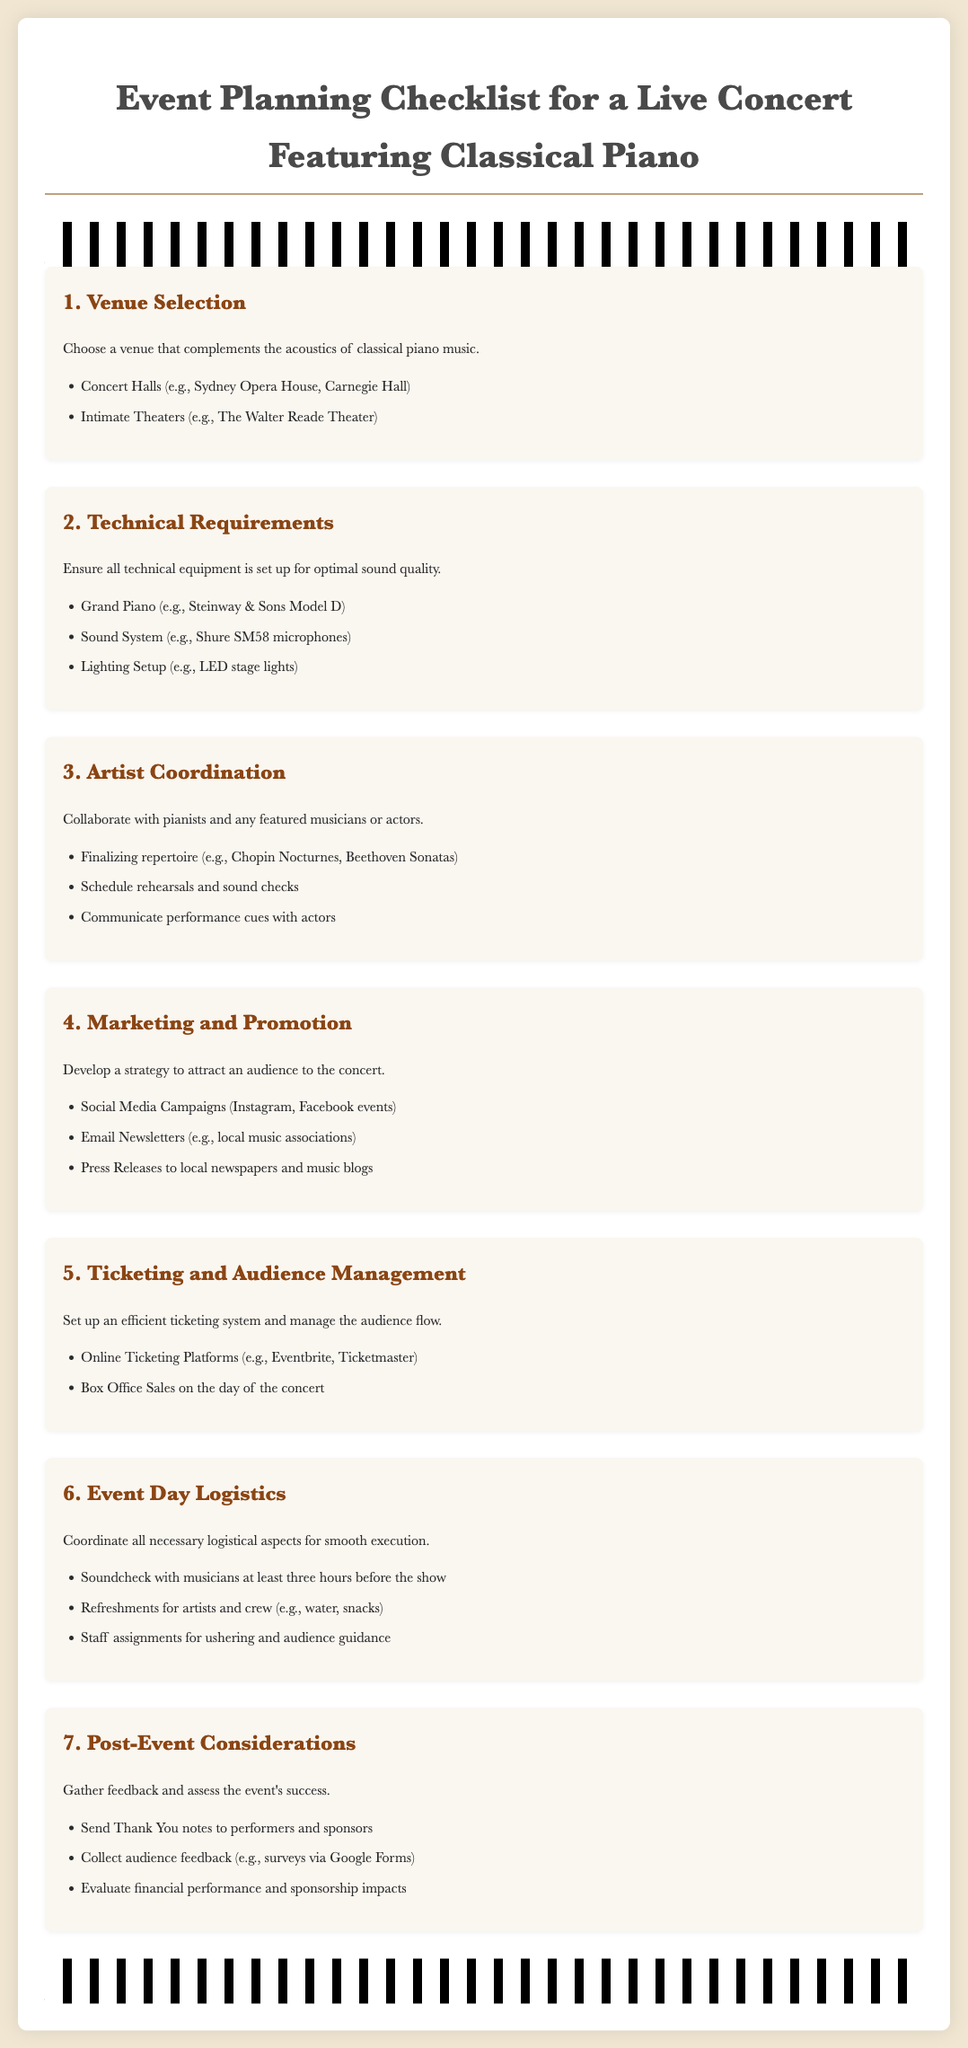What are two types of venues mentioned? The document lists different types of venues suitable for a classical piano concert, including concert halls and intimate theaters.
Answer: Concert Halls, Intimate Theaters What is one technical requirement for the concert? The document highlights a grand piano as one of the essential technical requirements for the concert.
Answer: Grand Piano How many hours before the show should the soundcheck be conducted? The checklist specifies that soundcheck with musicians should occur at least three hours before the show.
Answer: Three hours What is one strategy for marketing mentioned in the document? The document suggests using social media campaigns as a strategy to attract an audience to the concert.
Answer: Social Media Campaigns What is the purpose of sending Thank You notes after the event? The document states that sending Thank You notes is aimed at acknowledging the contributions of performers and sponsors after the concert.
Answer: Acknowledgment How should audience feedback be collected according to the checklist? The document recommends collecting audience feedback using surveys, specifically mentioning Google Forms as a method.
Answer: Surveys via Google Forms 